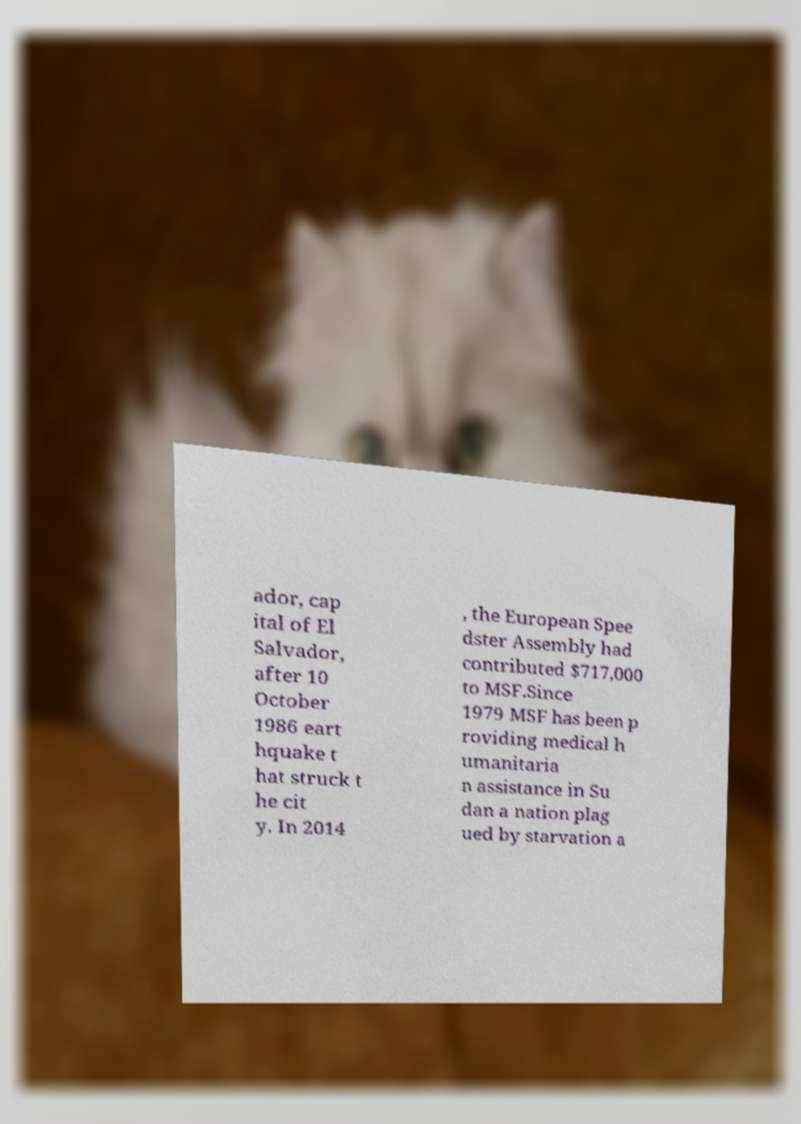I need the written content from this picture converted into text. Can you do that? ador, cap ital of El Salvador, after 10 October 1986 eart hquake t hat struck t he cit y. In 2014 , the European Spee dster Assembly had contributed $717,000 to MSF.Since 1979 MSF has been p roviding medical h umanitaria n assistance in Su dan a nation plag ued by starvation a 